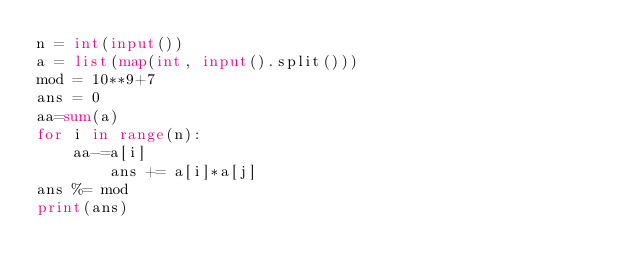Convert code to text. <code><loc_0><loc_0><loc_500><loc_500><_Python_>n = int(input())
a = list(map(int, input().split()))
mod = 10**9+7
ans = 0
aa=sum(a)
for i in range(n):
    aa-=a[i]
        ans += a[i]*a[j]
ans %= mod
print(ans)
</code> 